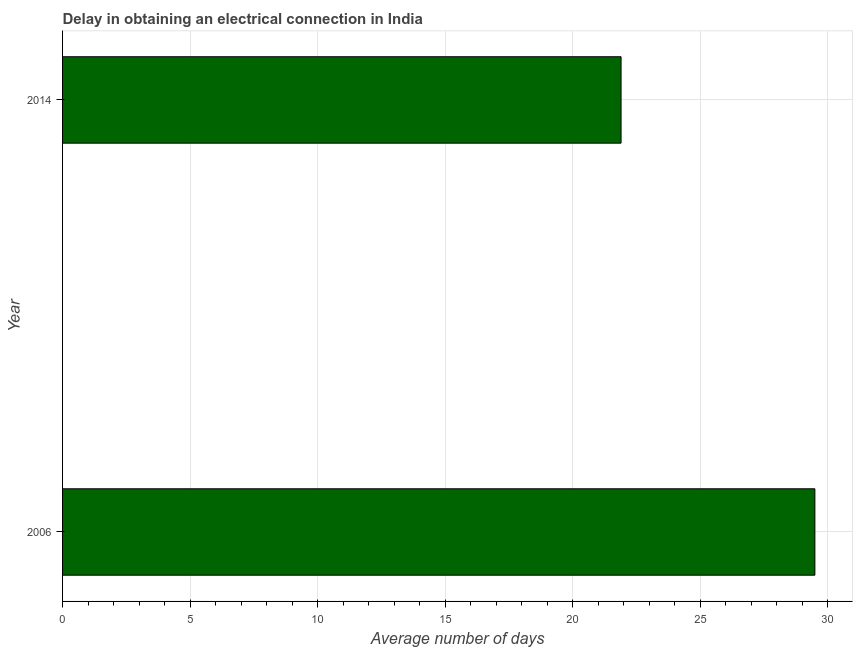Does the graph contain any zero values?
Ensure brevity in your answer.  No. What is the title of the graph?
Provide a short and direct response. Delay in obtaining an electrical connection in India. What is the label or title of the X-axis?
Provide a succinct answer. Average number of days. What is the label or title of the Y-axis?
Your response must be concise. Year. What is the dalay in electrical connection in 2014?
Ensure brevity in your answer.  21.9. Across all years, what is the maximum dalay in electrical connection?
Your answer should be compact. 29.5. Across all years, what is the minimum dalay in electrical connection?
Provide a succinct answer. 21.9. In which year was the dalay in electrical connection minimum?
Keep it short and to the point. 2014. What is the sum of the dalay in electrical connection?
Your response must be concise. 51.4. What is the difference between the dalay in electrical connection in 2006 and 2014?
Give a very brief answer. 7.6. What is the average dalay in electrical connection per year?
Give a very brief answer. 25.7. What is the median dalay in electrical connection?
Ensure brevity in your answer.  25.7. What is the ratio of the dalay in electrical connection in 2006 to that in 2014?
Your answer should be compact. 1.35. Is the dalay in electrical connection in 2006 less than that in 2014?
Offer a terse response. No. How many bars are there?
Give a very brief answer. 2. Are the values on the major ticks of X-axis written in scientific E-notation?
Keep it short and to the point. No. What is the Average number of days of 2006?
Keep it short and to the point. 29.5. What is the Average number of days in 2014?
Offer a very short reply. 21.9. What is the ratio of the Average number of days in 2006 to that in 2014?
Keep it short and to the point. 1.35. 